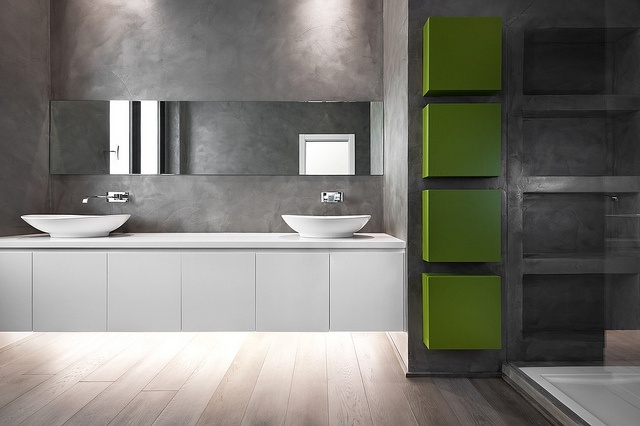Describe the objects in this image and their specific colors. I can see sink in gray, lightgray, darkgray, and black tones, sink in gray, gainsboro, darkgray, and lightgray tones, and sink in gray, lightgray, black, and darkgray tones in this image. 